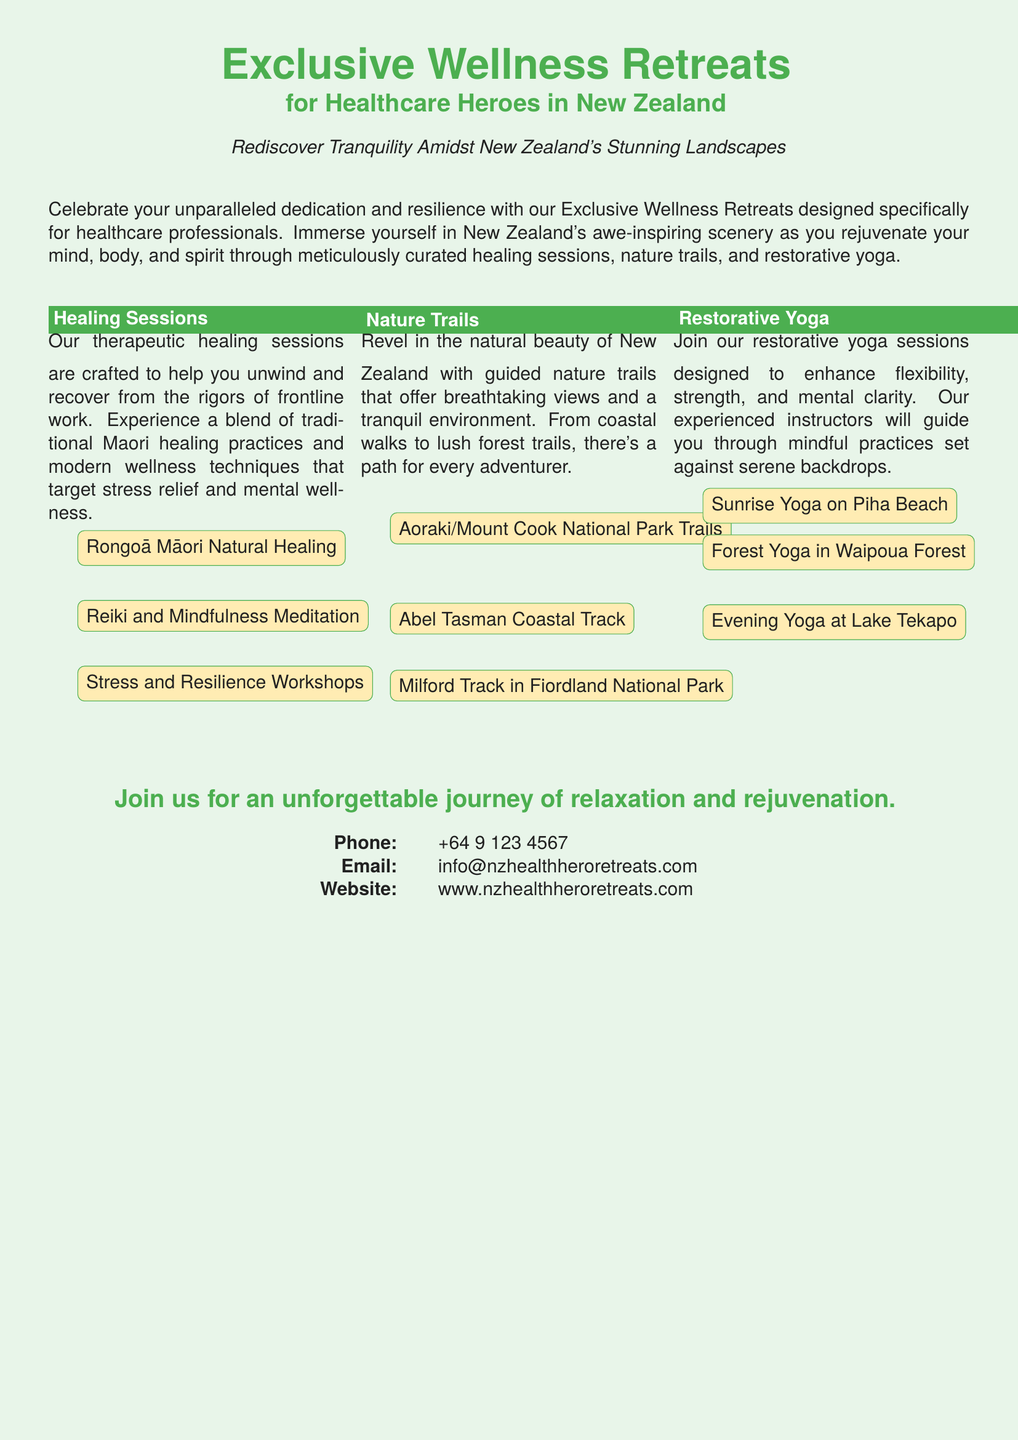What are the target participants of the retreats? The retreats are designed specifically for healthcare professionals.
Answer: Healthcare professionals What is the main theme of the advertisement? The main theme revolves around relaxation and rejuvenation in scenic New Zealand.
Answer: Relaxation and rejuvenation What healing practices are mentioned? The document lists traditional Maori healing practices and modern wellness techniques.
Answer: Rongoā Māori Natural Healing How many sections are there in the retreat? The advertisement includes three sections detailing different activities offered.
Answer: Three sections What is the contact email for inquiries? The document specifies an email address for further inquiries related to the retreats.
Answer: info@nzhealthheroretreats.com Which yoga session is offered at sunrise? The advertisement highlights a specific yoga session location during sunrise.
Answer: Sunrise Yoga on Piha Beach What type of environment do the nature trails provide? The document emphasizes the tranquility of the environment in the nature trails offered.
Answer: Tranquil environment What is the main focus of the restorative yoga sessions? The focus is on enhancing flexibility, strength, and mental clarity.
Answer: Flexibility, strength, and mental clarity What phone number is provided for contact? A specific phone number is listed for potential attendees to reach out.
Answer: +64 9 123 4567 Which national park has trails mentioned in the advertisement? The advertisement references Aoraki/Mount Cook National Park as one of the locations for nature trails.
Answer: Aoraki/Mount Cook National Park 